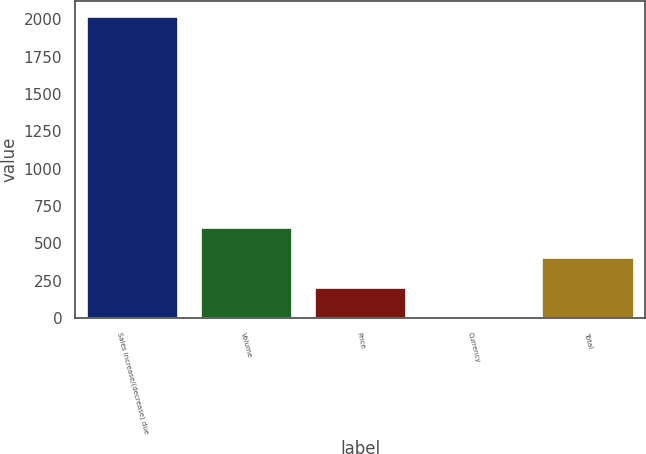<chart> <loc_0><loc_0><loc_500><loc_500><bar_chart><fcel>Sales increase/(decrease) due<fcel>Volume<fcel>Price<fcel>Currency<fcel>Total<nl><fcel>2018<fcel>605.68<fcel>202.16<fcel>0.4<fcel>403.92<nl></chart> 